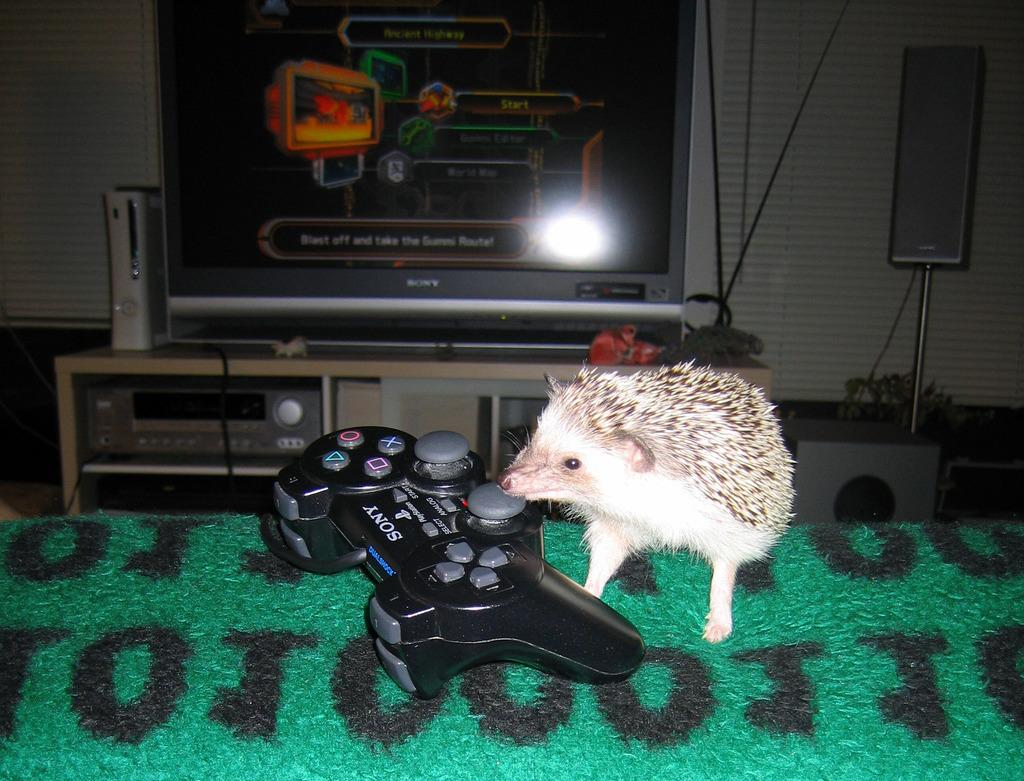What type of input device is in the image? There is a joystick and a mouse in the image. Where are the joystick and mouse located? Both the joystick and mouse are on a table. What can be seen in the background of the image? There is a television, a speaker, another table, and a wall in the background of the image. What type of can is visible in the image? There is no can present in the image. What taste is associated with the joystick and mouse in the image? The joystick and mouse are not associated with any taste, as they are input devices and not food items. 